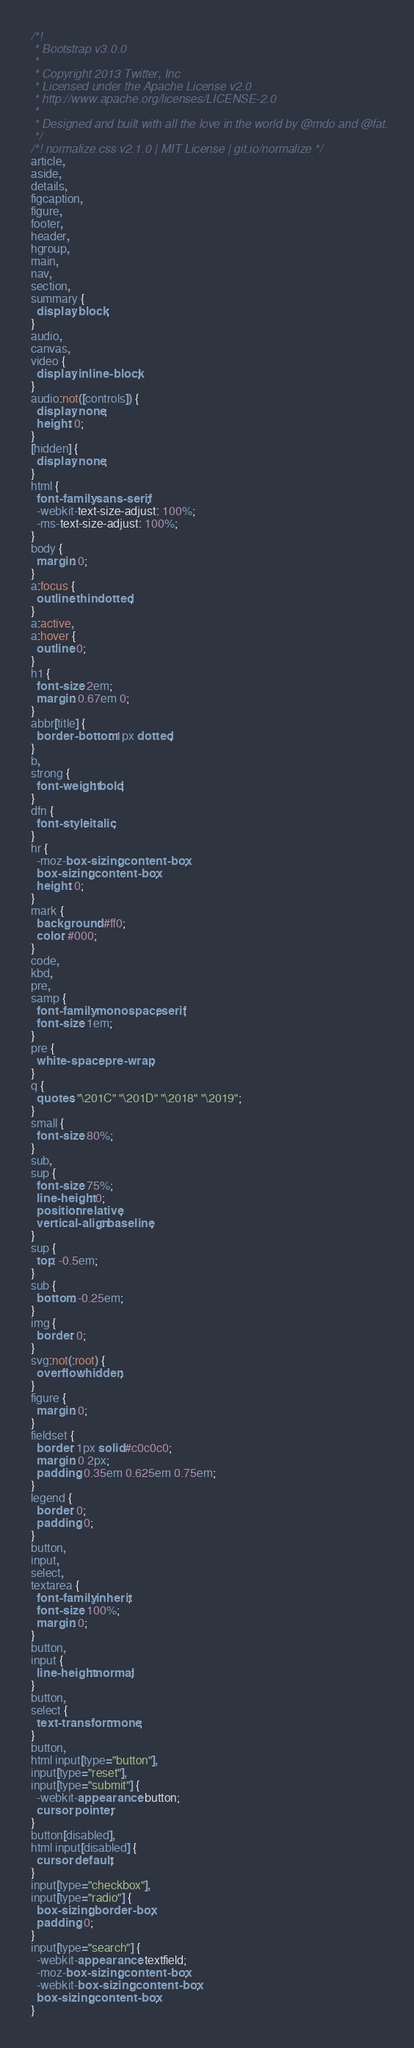Convert code to text. <code><loc_0><loc_0><loc_500><loc_500><_CSS_>/*!
 * Bootstrap v3.0.0
 *
 * Copyright 2013 Twitter, Inc
 * Licensed under the Apache License v2.0
 * http://www.apache.org/licenses/LICENSE-2.0
 *
 * Designed and built with all the love in the world by @mdo and @fat.
 */
/*! normalize.css v2.1.0 | MIT License | git.io/normalize */
article,
aside,
details,
figcaption,
figure,
footer,
header,
hgroup,
main,
nav,
section,
summary {
  display: block;
}
audio,
canvas,
video {
  display: inline-block;
}
audio:not([controls]) {
  display: none;
  height: 0;
}
[hidden] {
  display: none;
}
html {
  font-family: sans-serif;
  -webkit-text-size-adjust: 100%;
  -ms-text-size-adjust: 100%;
}
body {
  margin: 0;
}
a:focus {
  outline: thin dotted;
}
a:active,
a:hover {
  outline: 0;
}
h1 {
  font-size: 2em;
  margin: 0.67em 0;
}
abbr[title] {
  border-bottom: 1px dotted;
}
b,
strong {
  font-weight: bold;
}
dfn {
  font-style: italic;
}
hr {
  -moz-box-sizing: content-box;
  box-sizing: content-box;
  height: 0;
}
mark {
  background: #ff0;
  color: #000;
}
code,
kbd,
pre,
samp {
  font-family: monospace, serif;
  font-size: 1em;
}
pre {
  white-space: pre-wrap;
}
q {
  quotes: "\201C" "\201D" "\2018" "\2019";
}
small {
  font-size: 80%;
}
sub,
sup {
  font-size: 75%;
  line-height: 0;
  position: relative;
  vertical-align: baseline;
}
sup {
  top: -0.5em;
}
sub {
  bottom: -0.25em;
}
img {
  border: 0;
}
svg:not(:root) {
  overflow: hidden;
}
figure {
  margin: 0;
}
fieldset {
  border: 1px solid #c0c0c0;
  margin: 0 2px;
  padding: 0.35em 0.625em 0.75em;
}
legend {
  border: 0;
  padding: 0;
}
button,
input,
select,
textarea {
  font-family: inherit;
  font-size: 100%;
  margin: 0;
}
button,
input {
  line-height: normal;
}
button,
select {
  text-transform: none;
}
button,
html input[type="button"],
input[type="reset"],
input[type="submit"] {
  -webkit-appearance: button;
  cursor: pointer;
}
button[disabled],
html input[disabled] {
  cursor: default;
}
input[type="checkbox"],
input[type="radio"] {
  box-sizing: border-box;
  padding: 0;
}
input[type="search"] {
  -webkit-appearance: textfield;
  -moz-box-sizing: content-box;
  -webkit-box-sizing: content-box;
  box-sizing: content-box;
}</code> 